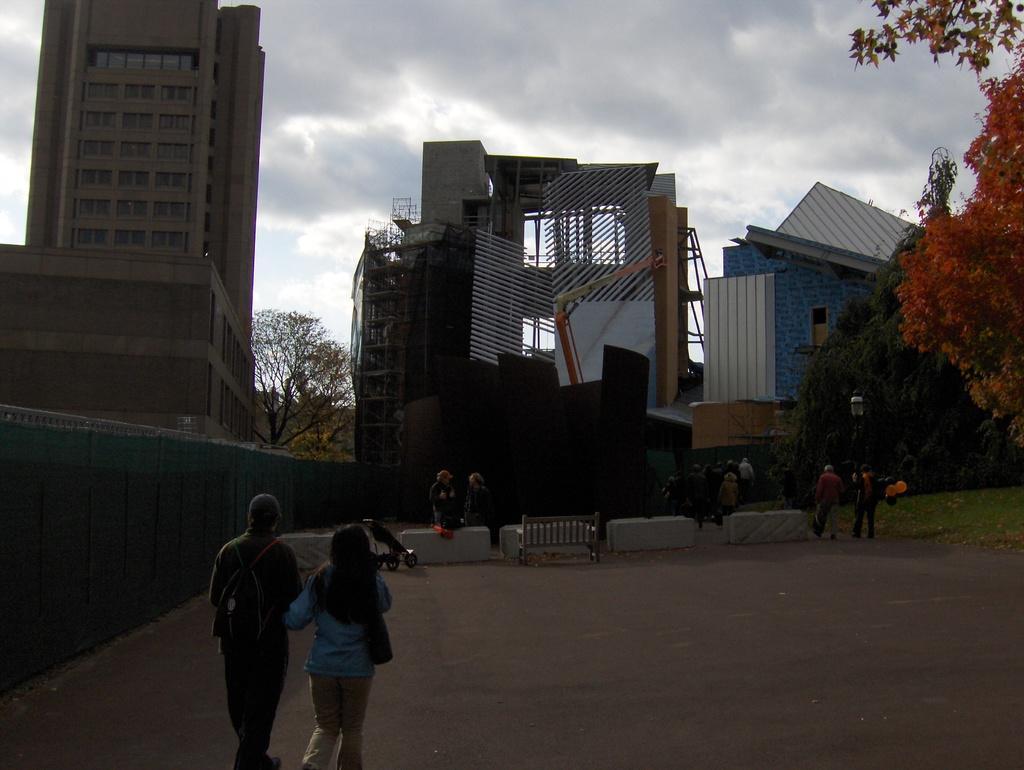Please provide a concise description of this image. In this image at the bottom there are some people who are walking, and in the background there are some buildings and trees. On the right side there is a wall, and at the bottom there is a walkway. 